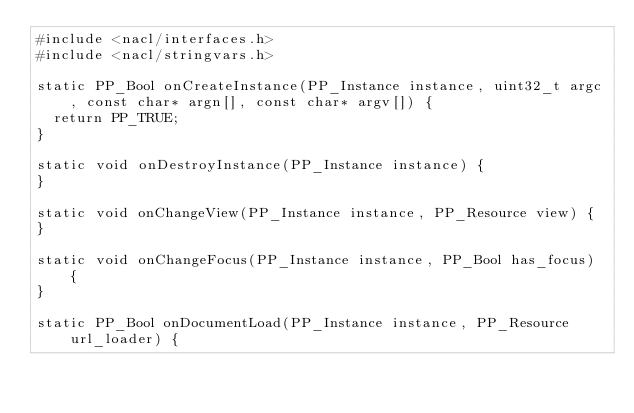<code> <loc_0><loc_0><loc_500><loc_500><_C_>#include <nacl/interfaces.h>
#include <nacl/stringvars.h>

static PP_Bool onCreateInstance(PP_Instance instance, uint32_t argc, const char* argn[], const char* argv[]) {
	return PP_TRUE;
}

static void onDestroyInstance(PP_Instance instance) {
}

static void onChangeView(PP_Instance instance, PP_Resource view) {
}

static void onChangeFocus(PP_Instance instance, PP_Bool has_focus) {
}

static PP_Bool onDocumentLoad(PP_Instance instance, PP_Resource url_loader) {</code> 